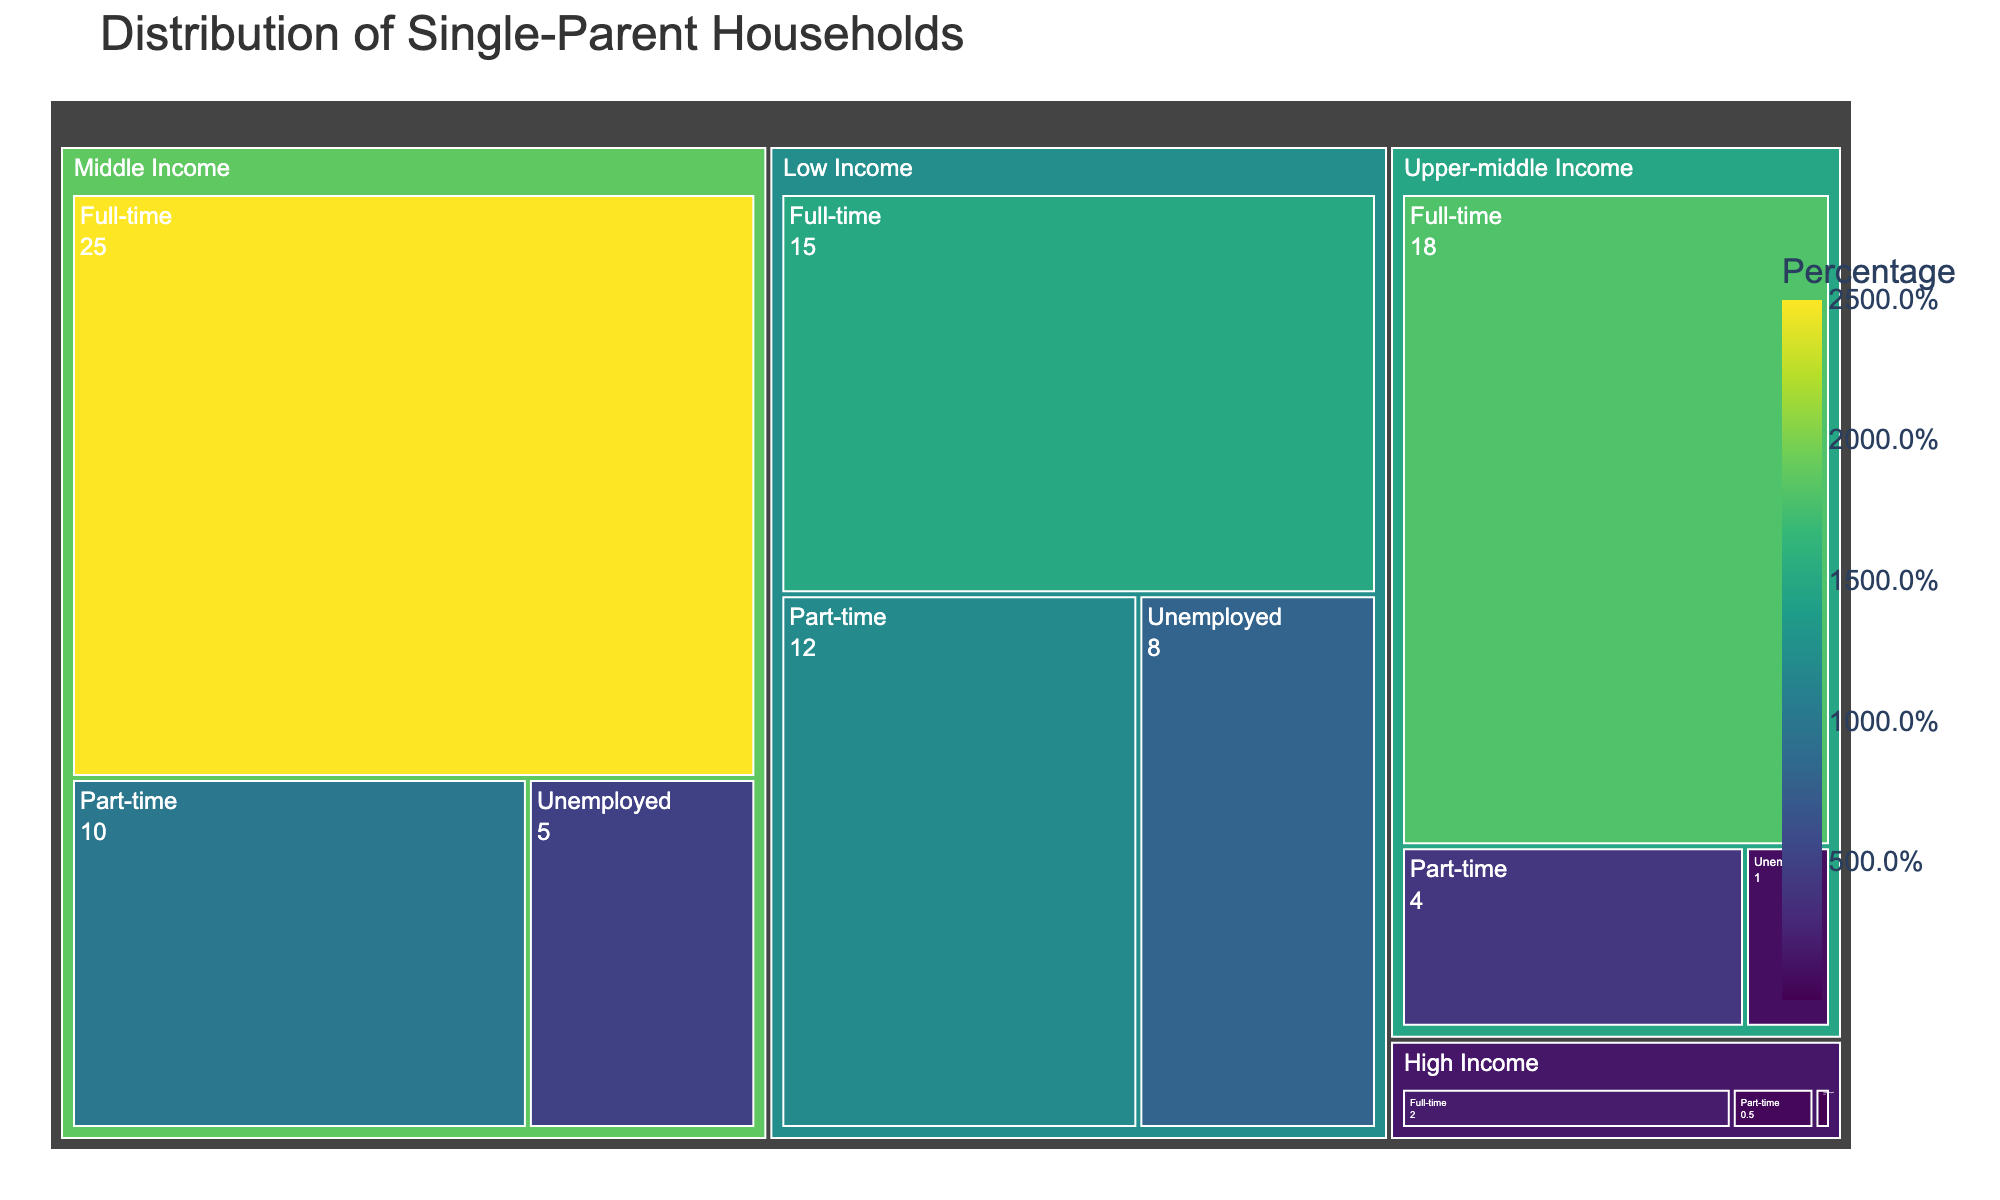What is the title of the treemap? The title of a plot is generally located at the top and gives a summary of what the figure represents. In this case, the title reads "Distribution of Single-Parent Households".
Answer: Distribution of Single-Parent Households Which income bracket has the largest percentage of single-parent households? To determine the income bracket with the largest percentage, observe the largest section within the treemap. The middle income bracket has the largest sections as compared to others.
Answer: Middle Income What is the percentage of single-parent households that are both low income and unemployed? Look for the segment representing the "Low Income" bracket and then locate the sub-segment labeled "Unemployed." The percentage is directly shown within that segment.
Answer: 8% How many different employment statuses are displayed within the high income bracket? Identify the "High Income" bracket on the treemap and count the number of subdivisions it has based on employment status.
Answer: 3 Which employment status has the smallest percentage in the upper-middle income bracket? Find the "Upper-middle Income" category and then determine which of the sub-segments has the smallest proportion. The "Unemployed" sub-segment is the smallest with 1%.
Answer: Unemployed Compare the percentage of full-time single parents in the middle income bracket to those in the upper-middle income bracket. Which is higher? Locate the "Full-time" sub-segments within both the "Middle Income" and "Upper-middle Income" brackets and compare their percentages. The middle income bracket has a higher percentage (25%) compared to the upper-middle income bracket (18%).
Answer: Middle Income What proportion of single-parent households are in the part-time employment category within the low income bracket? Go to the "Low Income" bracket and find the "Part-time" sub-segment. The percentage is 12%.
Answer: 12% Calculate the total percentage of single-parent households in the unemployed category across all income brackets. Sum up the percentages of the "Unemployed" category from all income brackets: 8% (Low Income) + 5% (Middle Income) + 1% (Upper-middle Income) + 0.1% (High Income) = 14.1%.
Answer: 14.1% Is the percentage of high income single-parent households higher for full-time or part-time employment? Compare the percentages of the "Full-time" and "Part-time" sub-segments under the "High Income" bracket. Full-time is 2% and part-time is 0.5%, so full-time is higher.
Answer: Full-time 